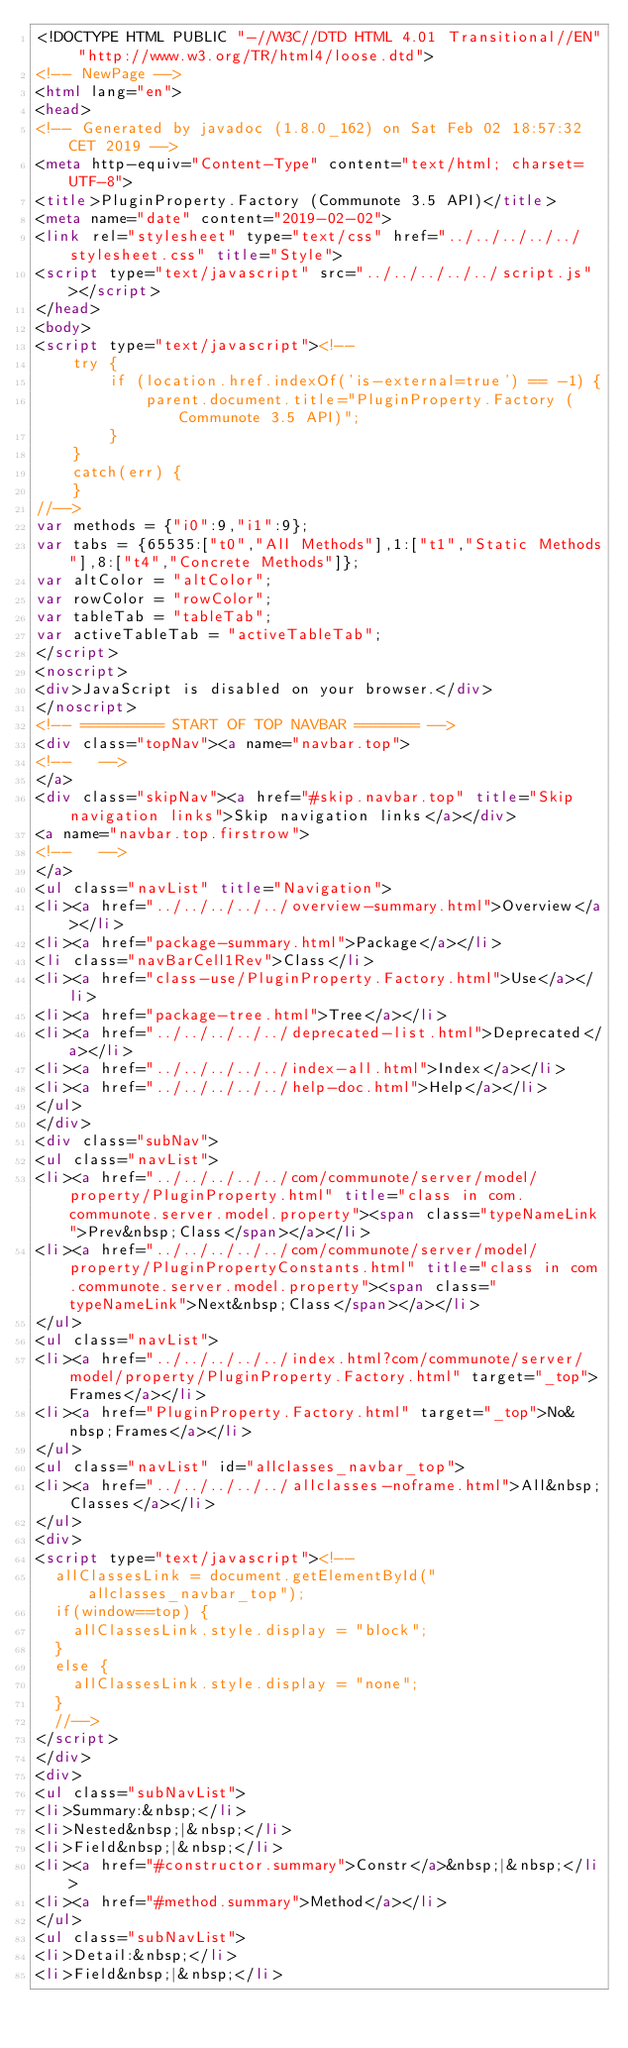<code> <loc_0><loc_0><loc_500><loc_500><_HTML_><!DOCTYPE HTML PUBLIC "-//W3C//DTD HTML 4.01 Transitional//EN" "http://www.w3.org/TR/html4/loose.dtd">
<!-- NewPage -->
<html lang="en">
<head>
<!-- Generated by javadoc (1.8.0_162) on Sat Feb 02 18:57:32 CET 2019 -->
<meta http-equiv="Content-Type" content="text/html; charset=UTF-8">
<title>PluginProperty.Factory (Communote 3.5 API)</title>
<meta name="date" content="2019-02-02">
<link rel="stylesheet" type="text/css" href="../../../../../stylesheet.css" title="Style">
<script type="text/javascript" src="../../../../../script.js"></script>
</head>
<body>
<script type="text/javascript"><!--
    try {
        if (location.href.indexOf('is-external=true') == -1) {
            parent.document.title="PluginProperty.Factory (Communote 3.5 API)";
        }
    }
    catch(err) {
    }
//-->
var methods = {"i0":9,"i1":9};
var tabs = {65535:["t0","All Methods"],1:["t1","Static Methods"],8:["t4","Concrete Methods"]};
var altColor = "altColor";
var rowColor = "rowColor";
var tableTab = "tableTab";
var activeTableTab = "activeTableTab";
</script>
<noscript>
<div>JavaScript is disabled on your browser.</div>
</noscript>
<!-- ========= START OF TOP NAVBAR ======= -->
<div class="topNav"><a name="navbar.top">
<!--   -->
</a>
<div class="skipNav"><a href="#skip.navbar.top" title="Skip navigation links">Skip navigation links</a></div>
<a name="navbar.top.firstrow">
<!--   -->
</a>
<ul class="navList" title="Navigation">
<li><a href="../../../../../overview-summary.html">Overview</a></li>
<li><a href="package-summary.html">Package</a></li>
<li class="navBarCell1Rev">Class</li>
<li><a href="class-use/PluginProperty.Factory.html">Use</a></li>
<li><a href="package-tree.html">Tree</a></li>
<li><a href="../../../../../deprecated-list.html">Deprecated</a></li>
<li><a href="../../../../../index-all.html">Index</a></li>
<li><a href="../../../../../help-doc.html">Help</a></li>
</ul>
</div>
<div class="subNav">
<ul class="navList">
<li><a href="../../../../../com/communote/server/model/property/PluginProperty.html" title="class in com.communote.server.model.property"><span class="typeNameLink">Prev&nbsp;Class</span></a></li>
<li><a href="../../../../../com/communote/server/model/property/PluginPropertyConstants.html" title="class in com.communote.server.model.property"><span class="typeNameLink">Next&nbsp;Class</span></a></li>
</ul>
<ul class="navList">
<li><a href="../../../../../index.html?com/communote/server/model/property/PluginProperty.Factory.html" target="_top">Frames</a></li>
<li><a href="PluginProperty.Factory.html" target="_top">No&nbsp;Frames</a></li>
</ul>
<ul class="navList" id="allclasses_navbar_top">
<li><a href="../../../../../allclasses-noframe.html">All&nbsp;Classes</a></li>
</ul>
<div>
<script type="text/javascript"><!--
  allClassesLink = document.getElementById("allclasses_navbar_top");
  if(window==top) {
    allClassesLink.style.display = "block";
  }
  else {
    allClassesLink.style.display = "none";
  }
  //-->
</script>
</div>
<div>
<ul class="subNavList">
<li>Summary:&nbsp;</li>
<li>Nested&nbsp;|&nbsp;</li>
<li>Field&nbsp;|&nbsp;</li>
<li><a href="#constructor.summary">Constr</a>&nbsp;|&nbsp;</li>
<li><a href="#method.summary">Method</a></li>
</ul>
<ul class="subNavList">
<li>Detail:&nbsp;</li>
<li>Field&nbsp;|&nbsp;</li></code> 